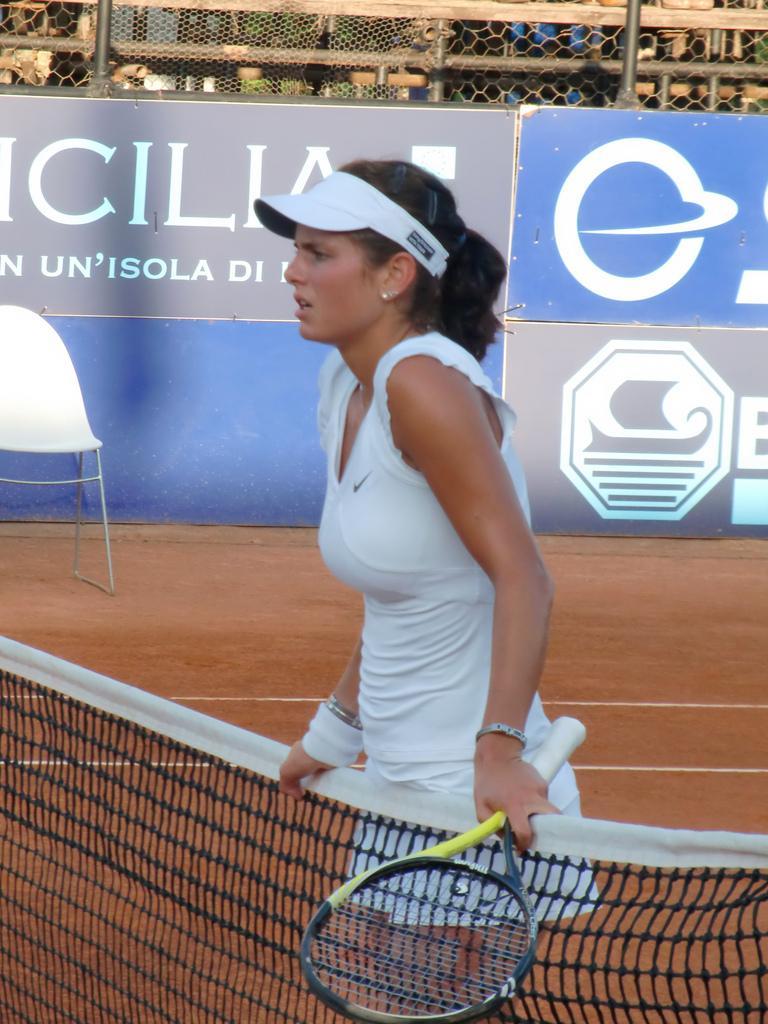Please provide a concise description of this image. On the background we can see hoardings and a chair near to it. Here we can see a women standing near to the net and she is holding a tennis racket in her hand. She wore a wristband to her hand. 